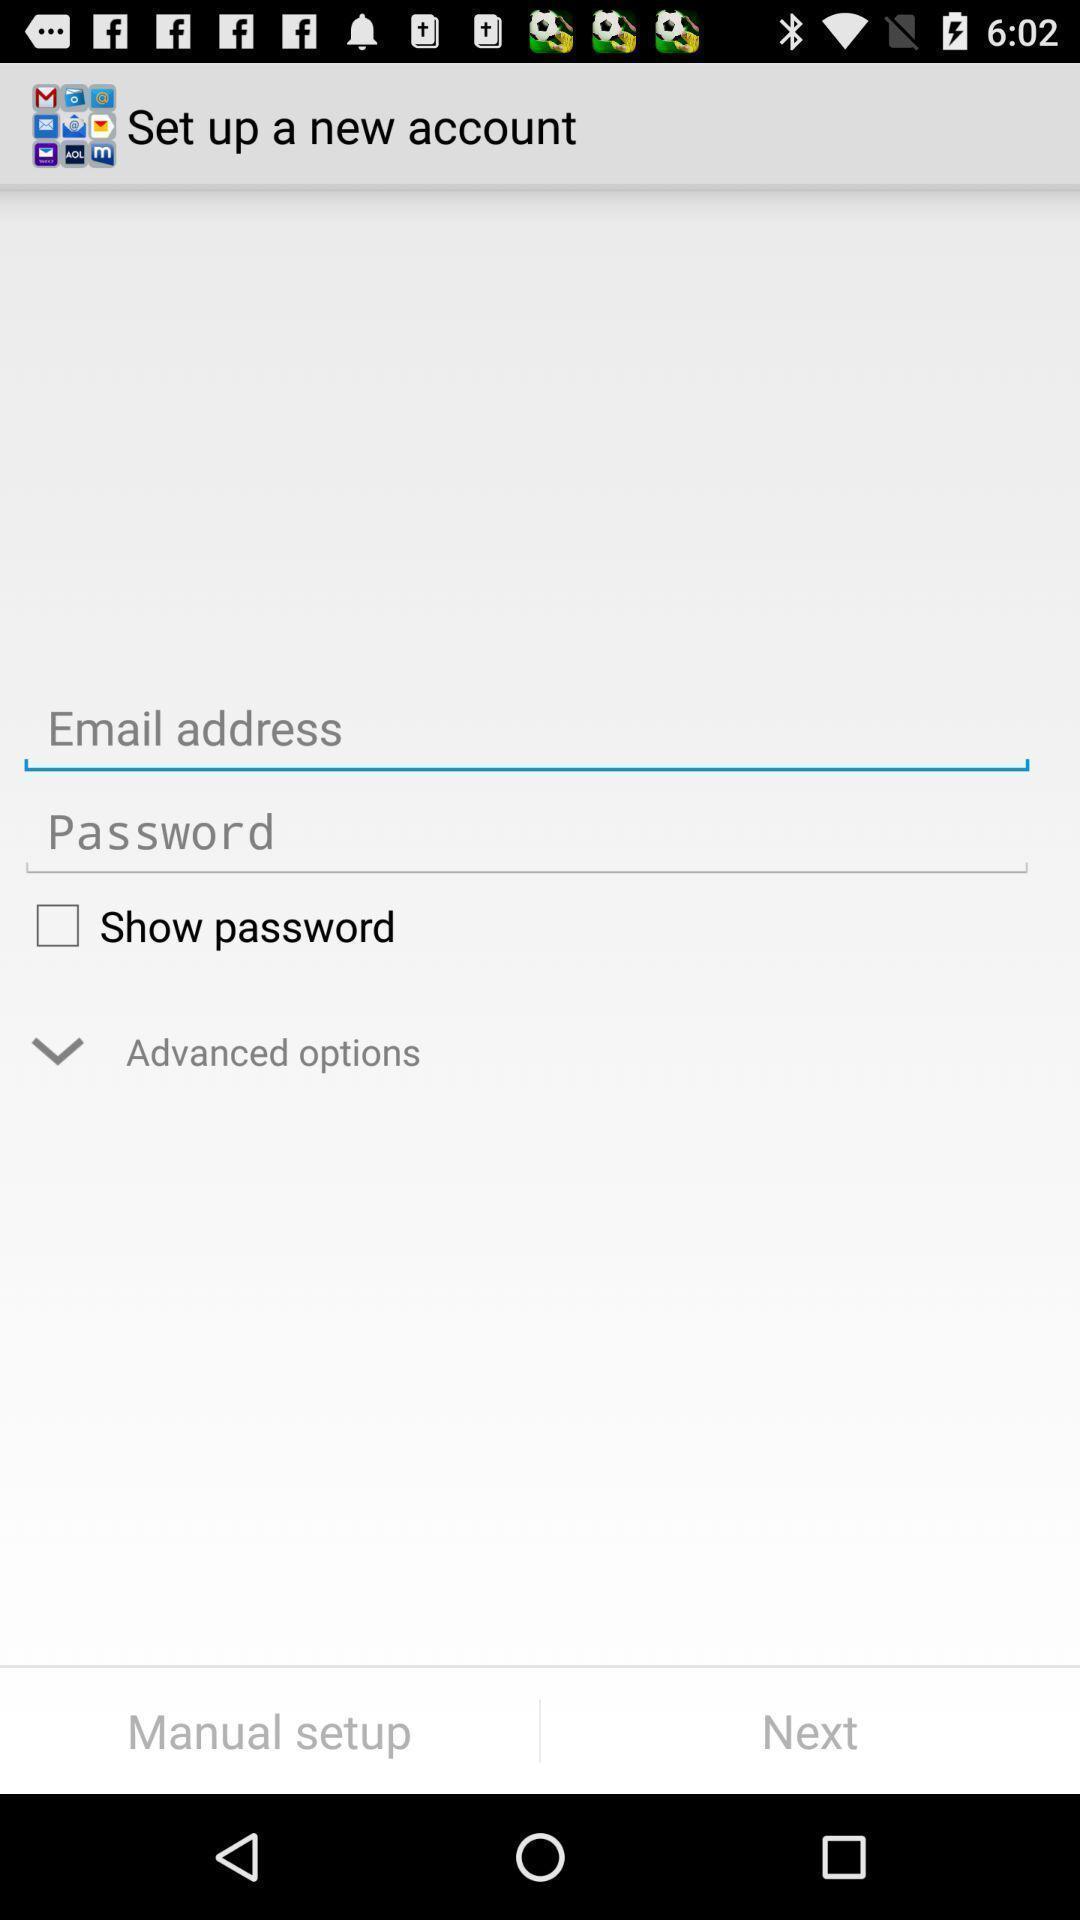Explain the elements present in this screenshot. Sign in page to set new account. 